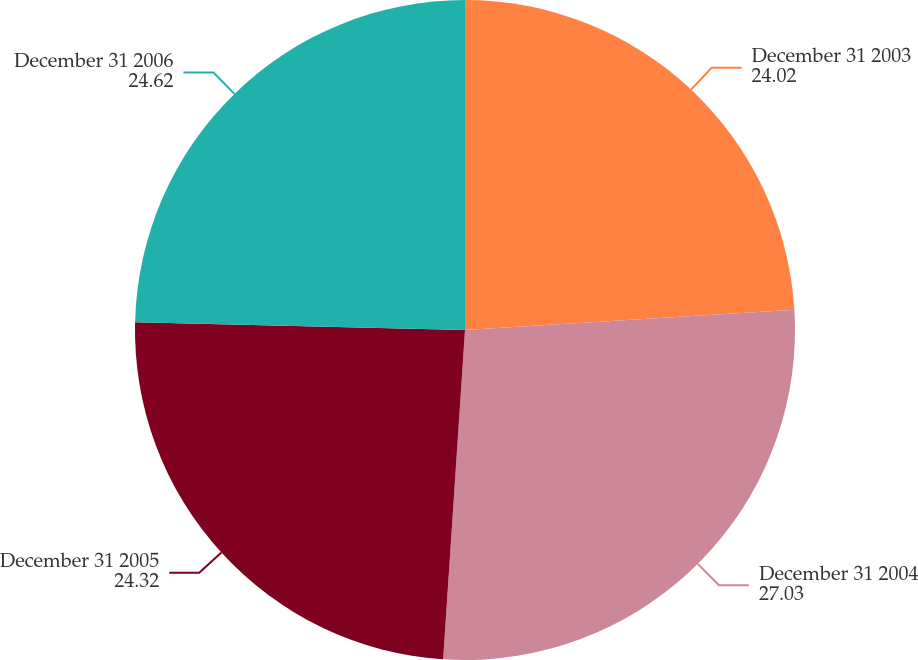Convert chart to OTSL. <chart><loc_0><loc_0><loc_500><loc_500><pie_chart><fcel>December 31 2003<fcel>December 31 2004<fcel>December 31 2005<fcel>December 31 2006<nl><fcel>24.02%<fcel>27.03%<fcel>24.32%<fcel>24.62%<nl></chart> 